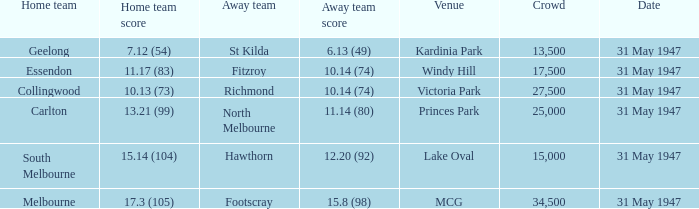What is the specified gathering when hawthorn is absent? 1.0. Can you give me this table as a dict? {'header': ['Home team', 'Home team score', 'Away team', 'Away team score', 'Venue', 'Crowd', 'Date'], 'rows': [['Geelong', '7.12 (54)', 'St Kilda', '6.13 (49)', 'Kardinia Park', '13,500', '31 May 1947'], ['Essendon', '11.17 (83)', 'Fitzroy', '10.14 (74)', 'Windy Hill', '17,500', '31 May 1947'], ['Collingwood', '10.13 (73)', 'Richmond', '10.14 (74)', 'Victoria Park', '27,500', '31 May 1947'], ['Carlton', '13.21 (99)', 'North Melbourne', '11.14 (80)', 'Princes Park', '25,000', '31 May 1947'], ['South Melbourne', '15.14 (104)', 'Hawthorn', '12.20 (92)', 'Lake Oval', '15,000', '31 May 1947'], ['Melbourne', '17.3 (105)', 'Footscray', '15.8 (98)', 'MCG', '34,500', '31 May 1947']]} 